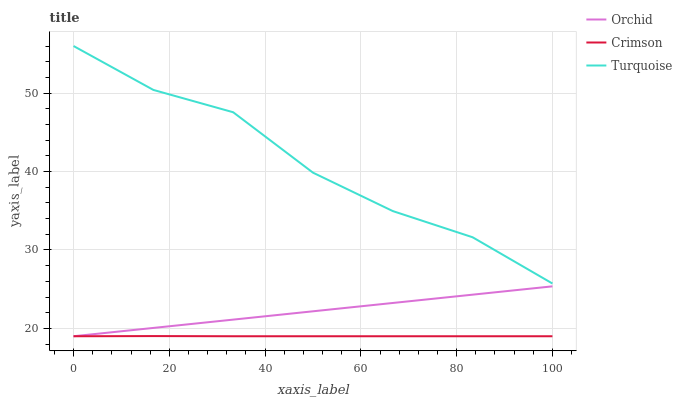Does Crimson have the minimum area under the curve?
Answer yes or no. Yes. Does Turquoise have the maximum area under the curve?
Answer yes or no. Yes. Does Orchid have the minimum area under the curve?
Answer yes or no. No. Does Orchid have the maximum area under the curve?
Answer yes or no. No. Is Orchid the smoothest?
Answer yes or no. Yes. Is Turquoise the roughest?
Answer yes or no. Yes. Is Turquoise the smoothest?
Answer yes or no. No. Is Orchid the roughest?
Answer yes or no. No. Does Crimson have the lowest value?
Answer yes or no. Yes. Does Turquoise have the lowest value?
Answer yes or no. No. Does Turquoise have the highest value?
Answer yes or no. Yes. Does Orchid have the highest value?
Answer yes or no. No. Is Orchid less than Turquoise?
Answer yes or no. Yes. Is Turquoise greater than Crimson?
Answer yes or no. Yes. Does Crimson intersect Orchid?
Answer yes or no. Yes. Is Crimson less than Orchid?
Answer yes or no. No. Is Crimson greater than Orchid?
Answer yes or no. No. Does Orchid intersect Turquoise?
Answer yes or no. No. 